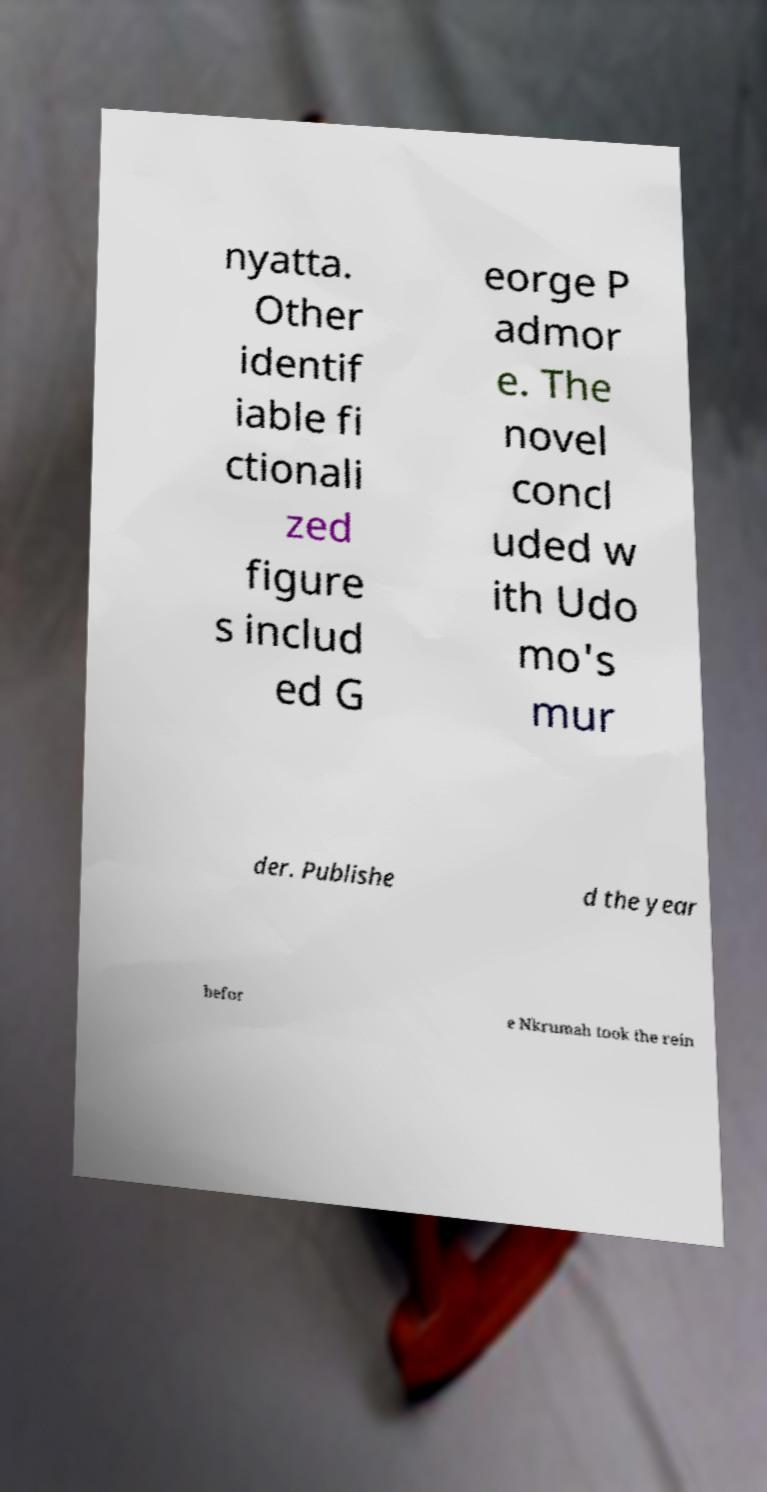For documentation purposes, I need the text within this image transcribed. Could you provide that? nyatta. Other identif iable fi ctionali zed figure s includ ed G eorge P admor e. The novel concl uded w ith Udo mo's mur der. Publishe d the year befor e Nkrumah took the rein 